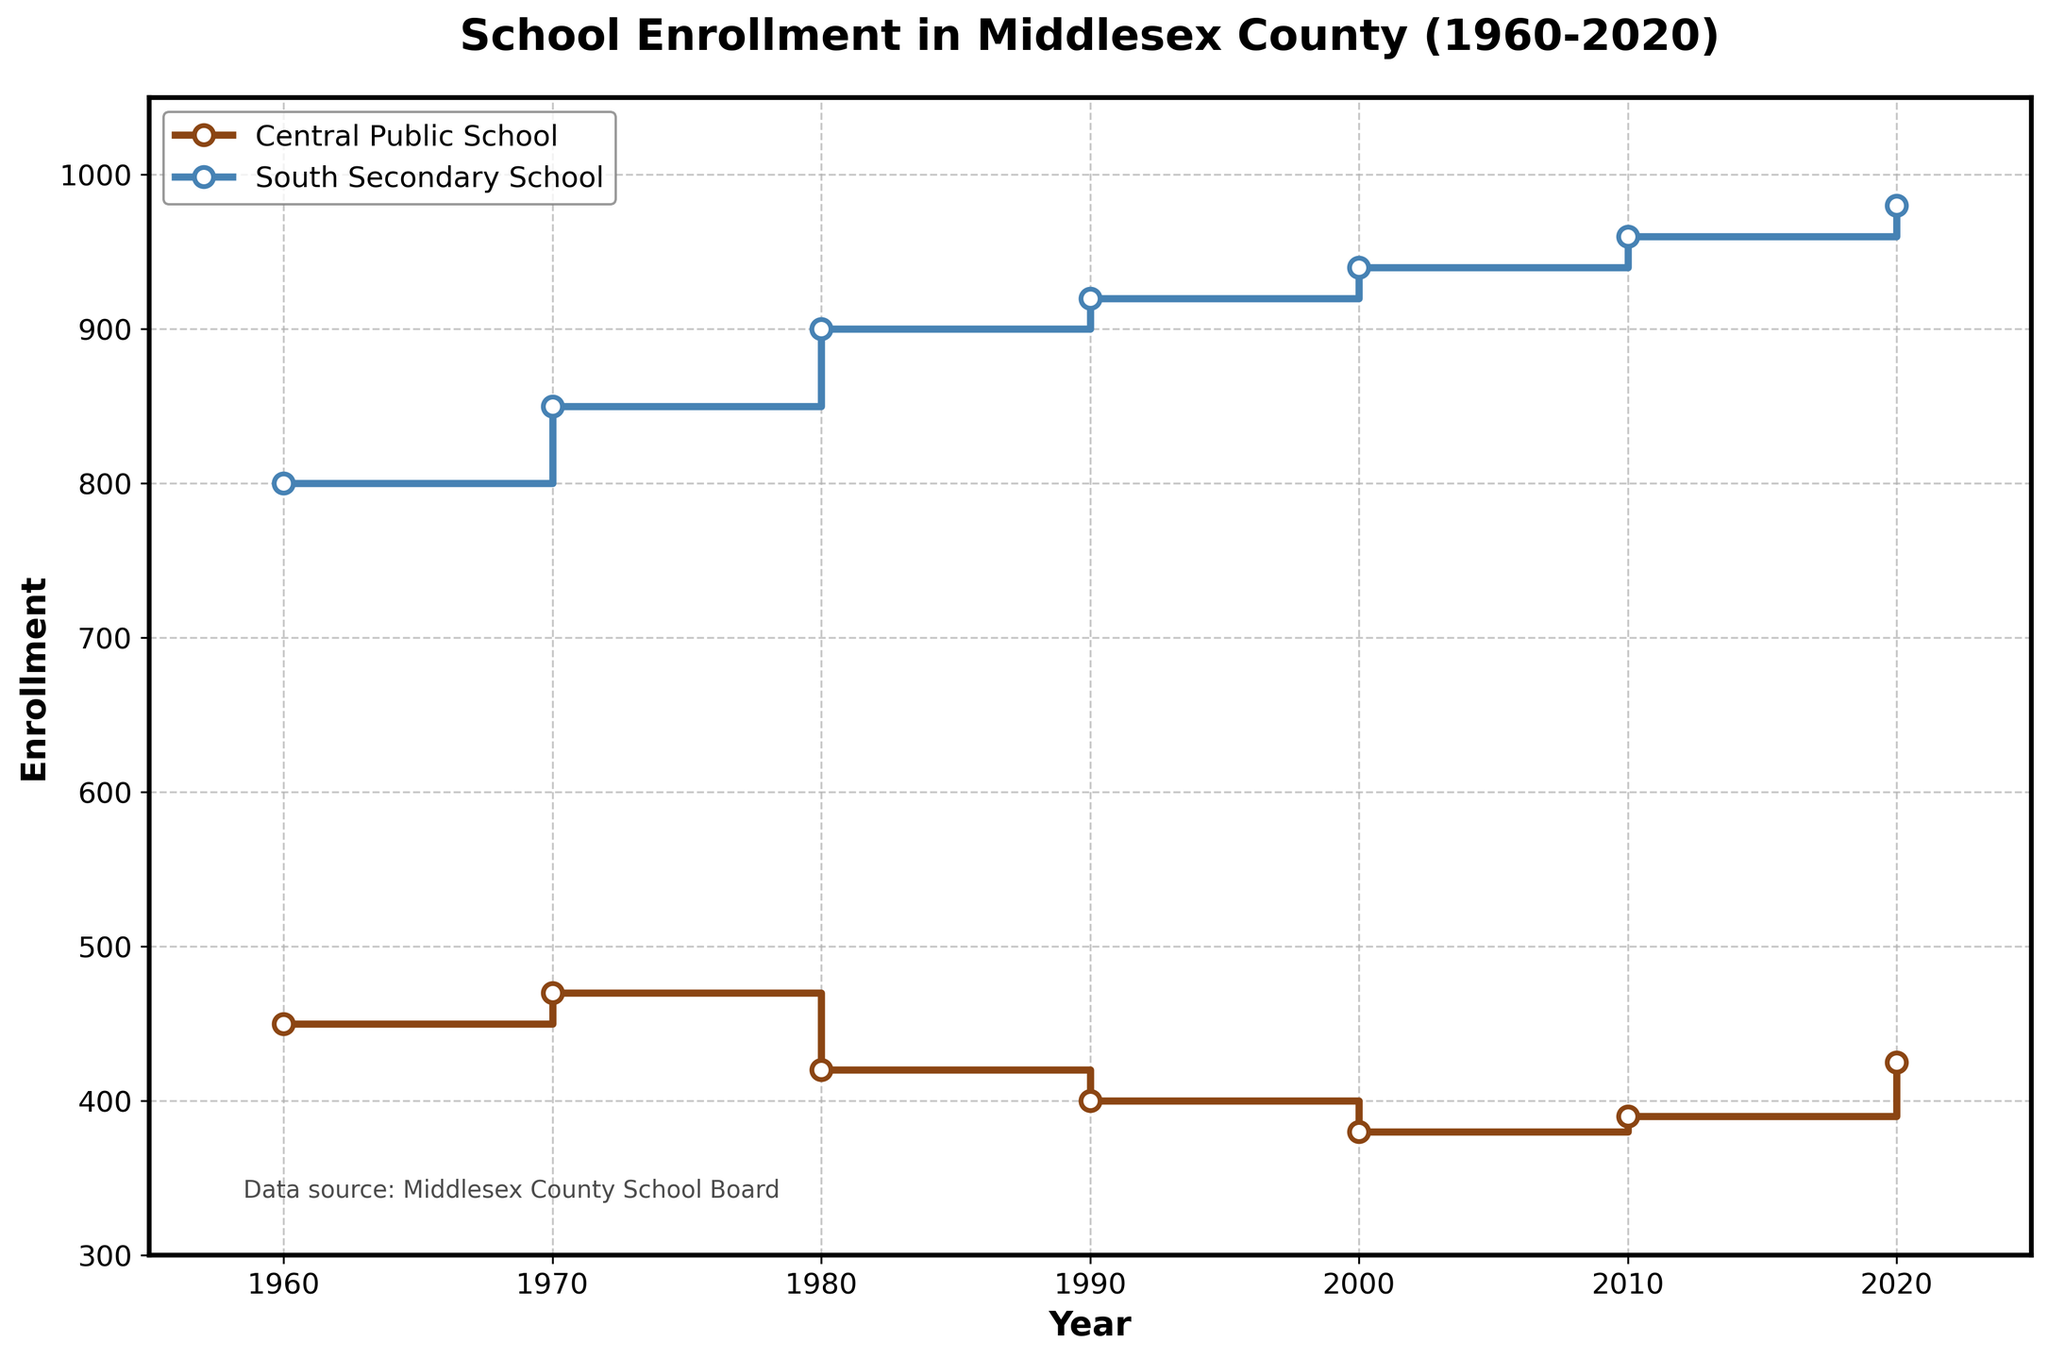What's the title of the figure? The title is typically at the top of the graph and usually summarized in a bold, larger font. In this case, it reads "School Enrollment in Middlesex County (1960-2020)"
Answer: School Enrollment in Middlesex County (1960-2020) What are the schools shown in the plot? The legend in the figure lists the names of the schools being compared, which are Central Public School and South Secondary School.
Answer: Central Public School, South Secondary School How often is data collected in the plot? By looking at the x-axis, we can see data points at intervals of ten years, starting from 1960 and ending at 2020. This indicates that data is collected every 10 years.
Answer: Every 10 years Which school had higher enrollment in 1990? Referring to the height of the steps for the year 1990 on the y-axis, Central Public School had around 400, while South Secondary School had around 920. Therefore, South Secondary School had a higher enrollment.
Answer: South Secondary School What is the trend of the percentage of ethnic minorities at Central Public School from 1960 to 2020? Over the years, the percentage of ethnic minorities at Central Public School has steadily increased, as shown by the increasing stair steps in the plot for this school.
Answer: Increasing Compare the enrollment between the two schools in 1980. By examining the heights of the steps in 1980, we see that Central Public School had an enrollment of around 420, whereas South Secondary School had about 900. South Secondary School had significantly higher enrollment.
Answer: South Secondary School What is the range of enrollments for South Secondary School from 1960 to 2020? By identifying the highest and lowest points of the steps for South Secondary School, we see that the lowest enrollment is 800 in 1960 and the highest is 980 in 2020. The range is calculated by subtracting the lowest from the highest, 980 - 800.
Answer: 180 Which school had an increasing trend in enrollment from 2000 to 2020? The steps for both schools should be observed between 2000 and 2020. Central Public School's enrollment increased from about 380 to 425, while South Secondary School's enrollment also increased from about 940 to 980. Both schools show an increasing trend.
Answer: Both schools In which year did Central Public School have the lowest enrollment and what was it? By looking at the lowest step for Central Public School, we see that the lowest enrollment occurred in 2000 with about 380 students.
Answer: 2000, 380 How does the enrollment change from 1960 to 2020 for South Secondary School? By tracing the steps for South Secondary School from 1960 (800) to 2020 (980), we can calculate the difference in enrollment which is 980 - 800. There is an increase of 180 students.
Answer: Increased by 180 